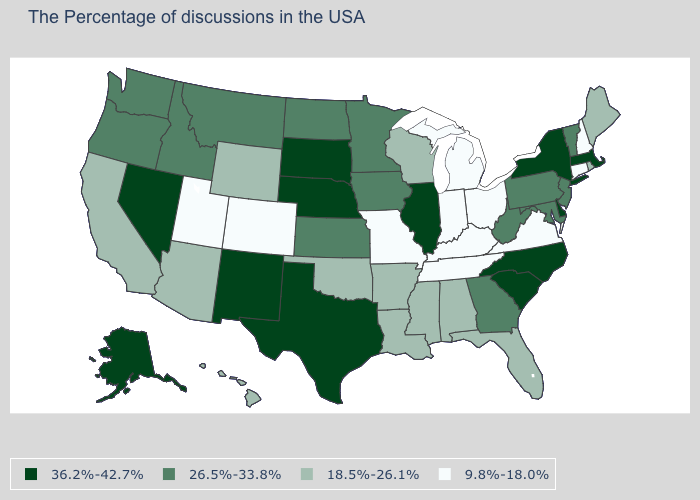Which states have the lowest value in the USA?
Give a very brief answer. New Hampshire, Connecticut, Virginia, Ohio, Michigan, Kentucky, Indiana, Tennessee, Missouri, Colorado, Utah. Does the first symbol in the legend represent the smallest category?
Answer briefly. No. What is the value of Arizona?
Give a very brief answer. 18.5%-26.1%. What is the value of West Virginia?
Write a very short answer. 26.5%-33.8%. What is the value of Tennessee?
Short answer required. 9.8%-18.0%. Does the map have missing data?
Concise answer only. No. Does California have a lower value than Colorado?
Write a very short answer. No. Among the states that border Florida , which have the lowest value?
Keep it brief. Alabama. What is the value of Maine?
Short answer required. 18.5%-26.1%. What is the value of Maine?
Answer briefly. 18.5%-26.1%. What is the value of Alaska?
Answer briefly. 36.2%-42.7%. Name the states that have a value in the range 9.8%-18.0%?
Be succinct. New Hampshire, Connecticut, Virginia, Ohio, Michigan, Kentucky, Indiana, Tennessee, Missouri, Colorado, Utah. Which states have the lowest value in the West?
Be succinct. Colorado, Utah. Among the states that border Louisiana , which have the lowest value?
Answer briefly. Mississippi, Arkansas. 